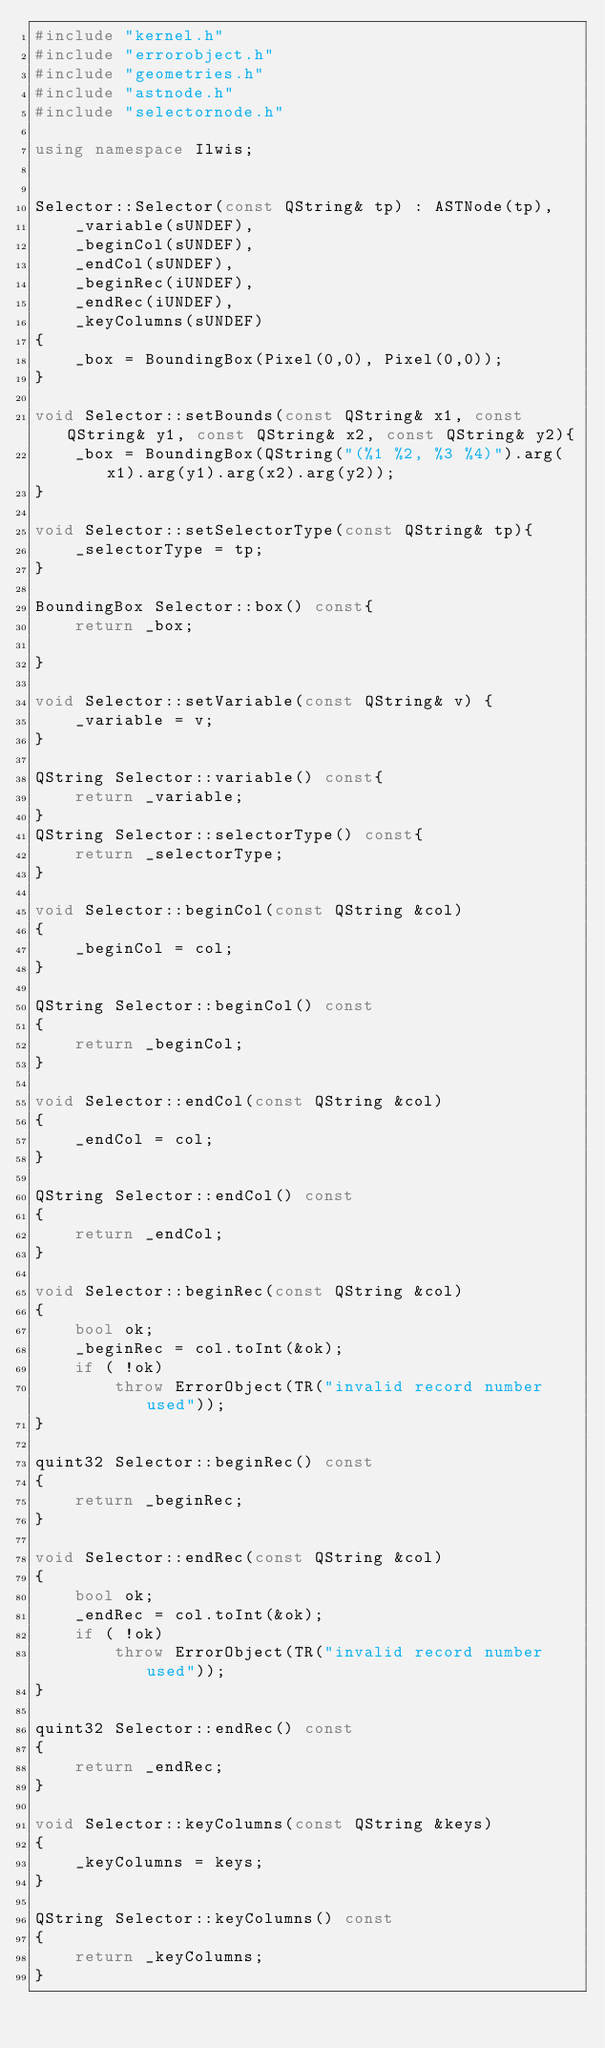<code> <loc_0><loc_0><loc_500><loc_500><_C++_>#include "kernel.h"
#include "errorobject.h"
#include "geometries.h"
#include "astnode.h"
#include "selectornode.h"

using namespace Ilwis;


Selector::Selector(const QString& tp) : ASTNode(tp),
    _variable(sUNDEF),
    _beginCol(sUNDEF),
    _endCol(sUNDEF),
    _beginRec(iUNDEF),
    _endRec(iUNDEF),
    _keyColumns(sUNDEF)
{
    _box = BoundingBox(Pixel(0,0), Pixel(0,0));
}

void Selector::setBounds(const QString& x1, const QString& y1, const QString& x2, const QString& y2){
    _box = BoundingBox(QString("(%1 %2, %3 %4)").arg(x1).arg(y1).arg(x2).arg(y2));
}

void Selector::setSelectorType(const QString& tp){
    _selectorType = tp;
}

BoundingBox Selector::box() const{
    return _box;

}

void Selector::setVariable(const QString& v) {
    _variable = v;
}

QString Selector::variable() const{
    return _variable;
}
QString Selector::selectorType() const{
    return _selectorType;
}

void Selector::beginCol(const QString &col)
{
    _beginCol = col;
}

QString Selector::beginCol() const
{
    return _beginCol;
}

void Selector::endCol(const QString &col)
{
    _endCol = col;
}

QString Selector::endCol() const
{
    return _endCol;
}

void Selector::beginRec(const QString &col)
{
    bool ok;
    _beginRec = col.toInt(&ok);
    if ( !ok)
        throw ErrorObject(TR("invalid record number used"));
}

quint32 Selector::beginRec() const
{
    return _beginRec;
}

void Selector::endRec(const QString &col)
{
    bool ok;
    _endRec = col.toInt(&ok);
    if ( !ok)
        throw ErrorObject(TR("invalid record number used"));
}

quint32 Selector::endRec() const
{
    return _endRec;
}

void Selector::keyColumns(const QString &keys)
{
    _keyColumns = keys;
}

QString Selector::keyColumns() const
{
    return _keyColumns;
}


</code> 